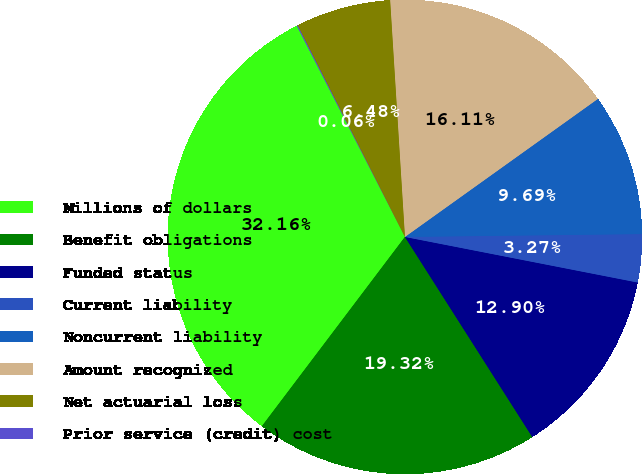<chart> <loc_0><loc_0><loc_500><loc_500><pie_chart><fcel>Millions of dollars<fcel>Benefit obligations<fcel>Funded status<fcel>Current liability<fcel>Noncurrent liability<fcel>Amount recognized<fcel>Net actuarial loss<fcel>Prior service (credit) cost<nl><fcel>32.16%<fcel>19.32%<fcel>12.9%<fcel>3.27%<fcel>9.69%<fcel>16.11%<fcel>6.48%<fcel>0.06%<nl></chart> 